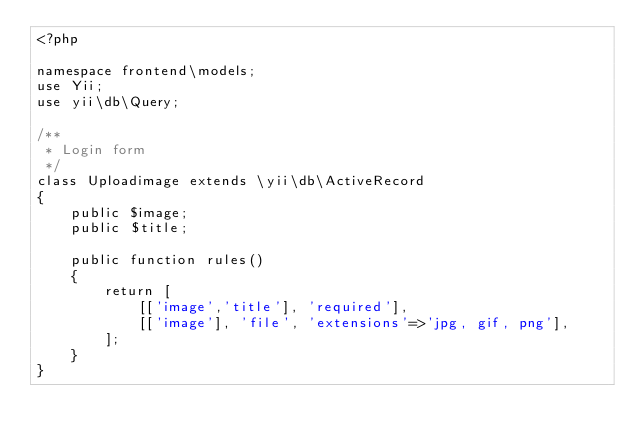<code> <loc_0><loc_0><loc_500><loc_500><_PHP_><?php

namespace frontend\models;
use Yii;
use yii\db\Query;

/**
 * Login form
 */
class Uploadimage extends \yii\db\ActiveRecord
{
    public $image;
    public $title;
    
    public function rules()
    {
        return [
            [['image','title'], 'required'],
            [['image'], 'file', 'extensions'=>'jpg, gif, png'],
        ];
    }
}
</code> 